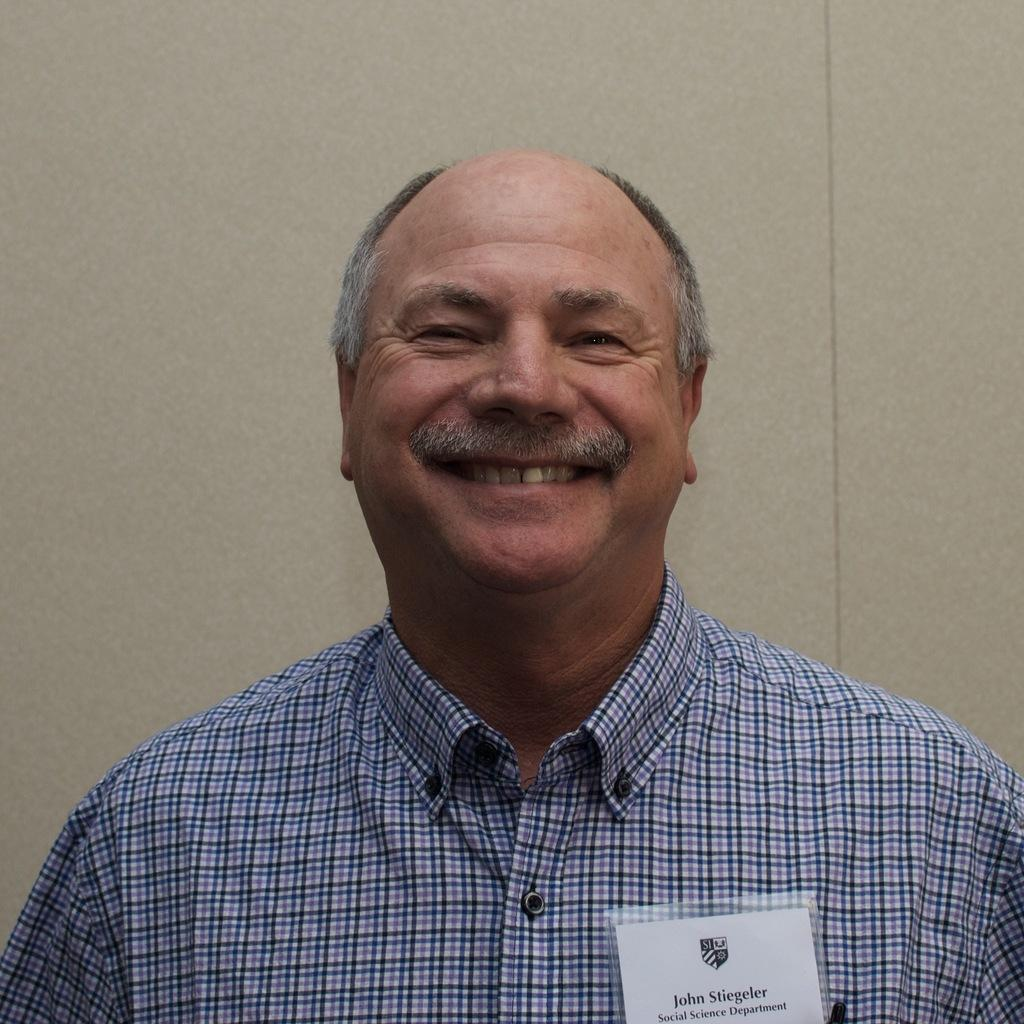Who is the main subject in the image? There is an old man in the image. What is the old man doing in the image? The old man is watching and smiling. What is the old man wearing in the image? The old man is wearing a shirt. What can be seen in the background of the image? There is a wall in the background of the image. What is the old man observing in the image? The old man is watching a batch in the image. How does the old man transport the batch in the image? The image does not show the old man transporting the batch; he is simply watching it. Can you describe how the old man stretches the batch in the image? There is no indication in the image that the old man is stretching the batch; he is only watching it. 